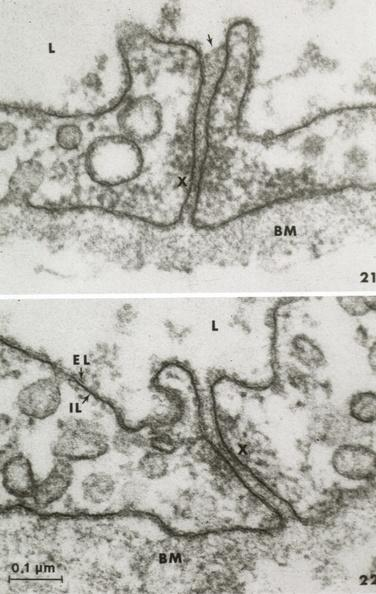where is this mage from?
Answer the question using a single word or phrase. Capillary 